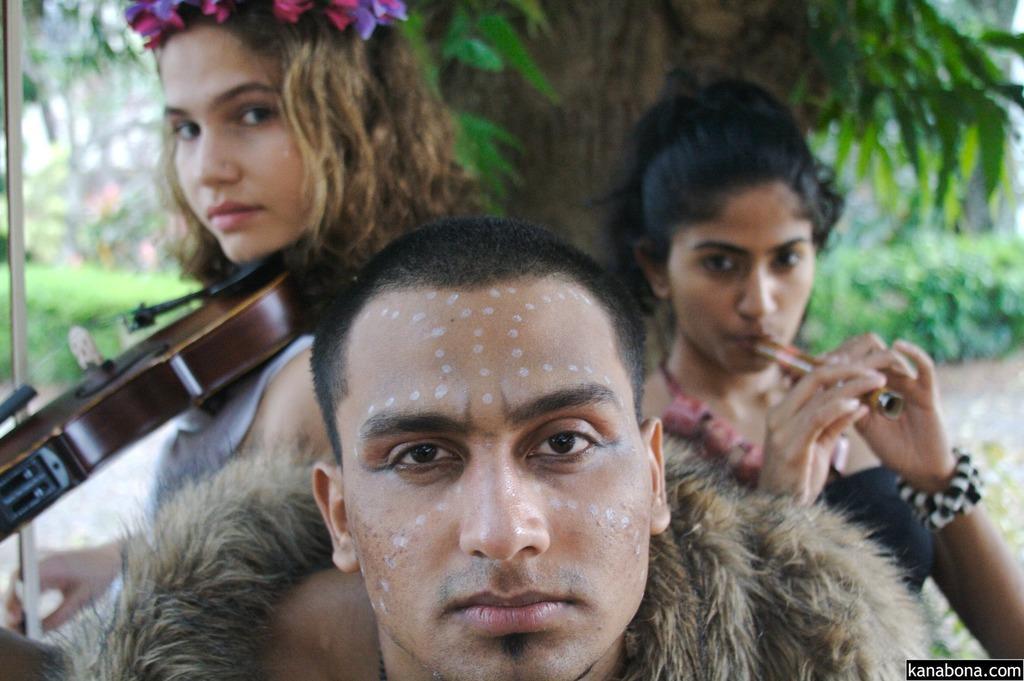In one or two sentences, can you explain what this image depicts? In this picture, we see three people. Woman on the right corner of the picture is playing flute. Woman on the left corner of picture is playing violin and man in front of the picture is standing. Behind them, we see tree and plants. 